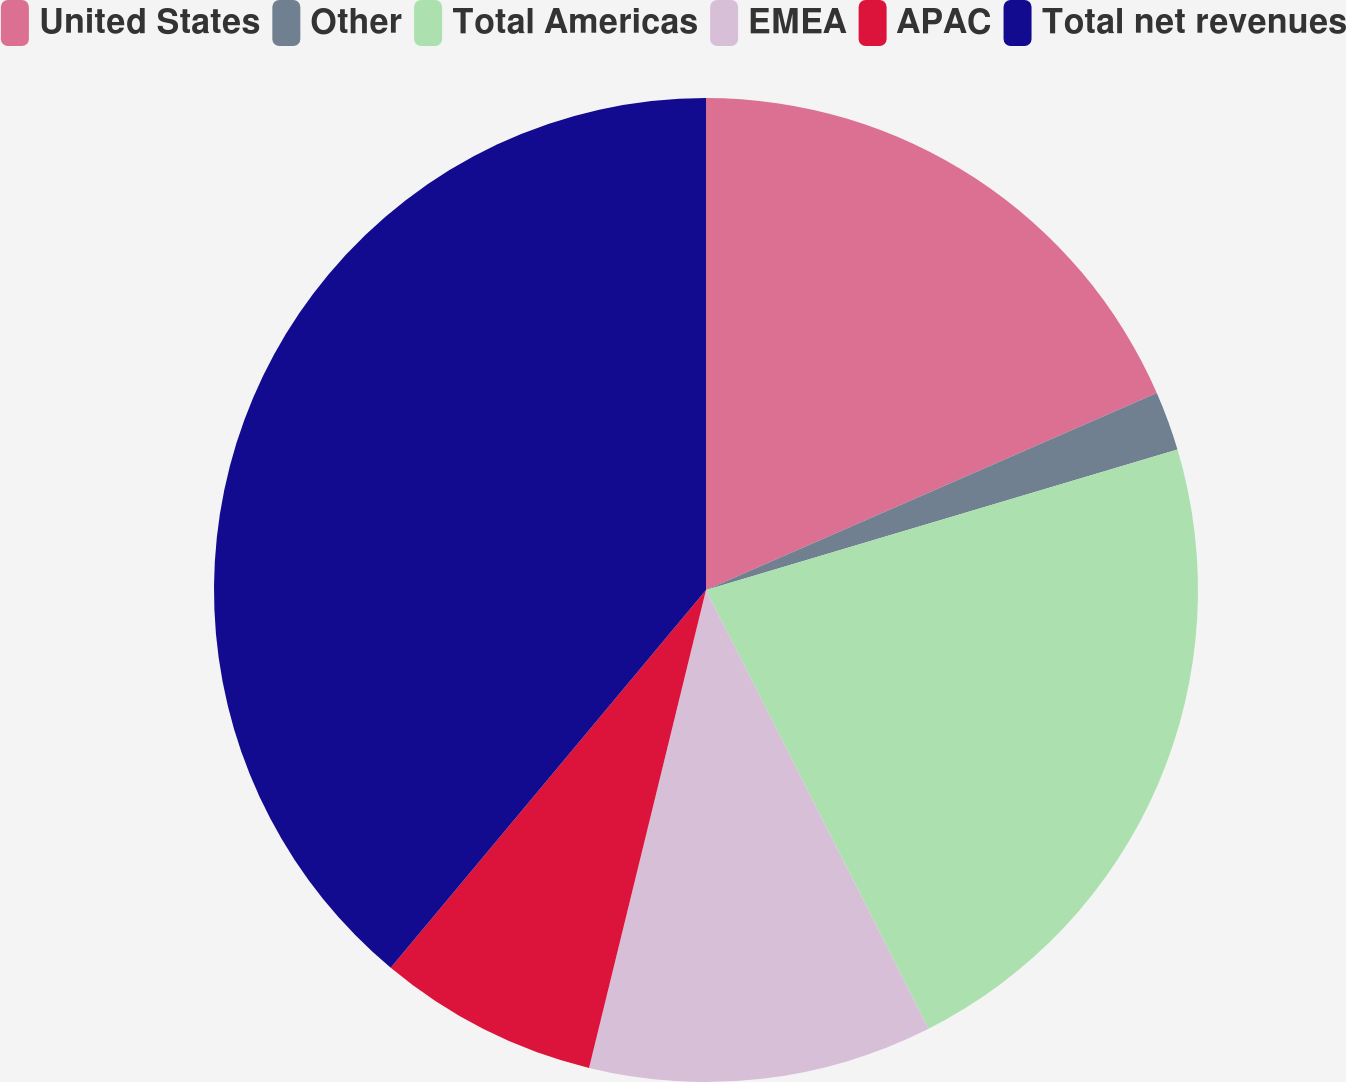<chart> <loc_0><loc_0><loc_500><loc_500><pie_chart><fcel>United States<fcel>Other<fcel>Total Americas<fcel>EMEA<fcel>APAC<fcel>Total net revenues<nl><fcel>18.44%<fcel>1.95%<fcel>22.14%<fcel>11.29%<fcel>7.25%<fcel>38.93%<nl></chart> 